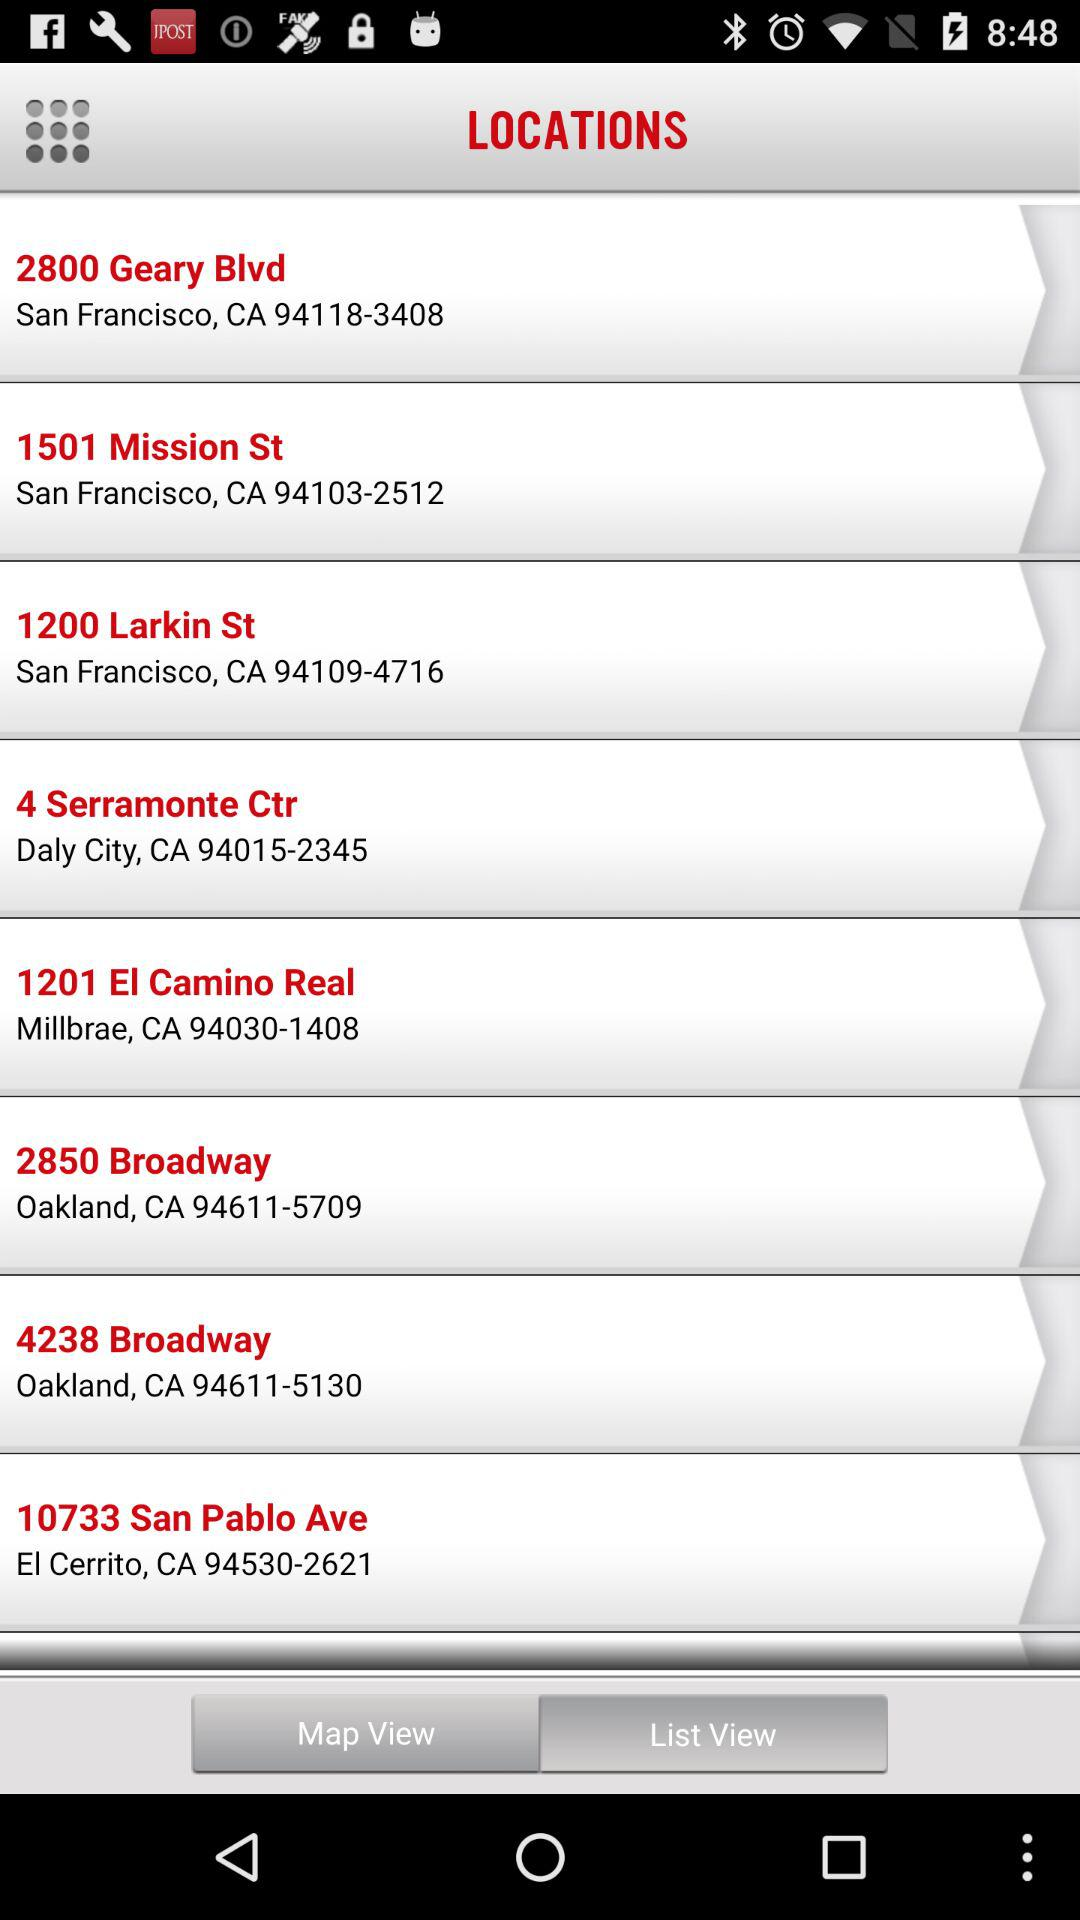What is the phone number for 2800 Geary Blvd? The phone number for 2800 Geary Blvd is 94118-3408. 